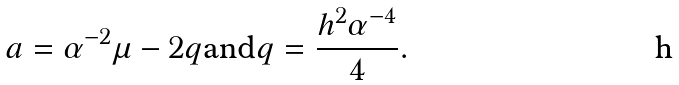Convert formula to latex. <formula><loc_0><loc_0><loc_500><loc_500>a = \alpha ^ { - 2 } \mu - 2 q \text {and} q = \frac { h ^ { 2 } \alpha ^ { - 4 } } { 4 } .</formula> 